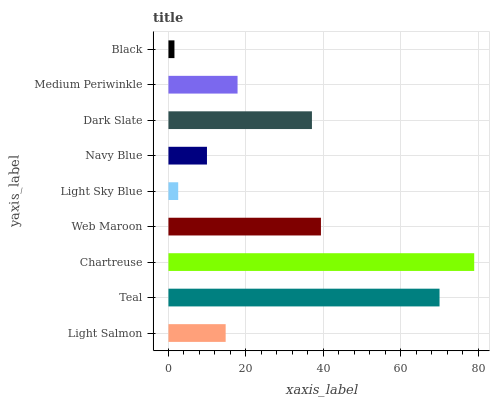Is Black the minimum?
Answer yes or no. Yes. Is Chartreuse the maximum?
Answer yes or no. Yes. Is Teal the minimum?
Answer yes or no. No. Is Teal the maximum?
Answer yes or no. No. Is Teal greater than Light Salmon?
Answer yes or no. Yes. Is Light Salmon less than Teal?
Answer yes or no. Yes. Is Light Salmon greater than Teal?
Answer yes or no. No. Is Teal less than Light Salmon?
Answer yes or no. No. Is Medium Periwinkle the high median?
Answer yes or no. Yes. Is Medium Periwinkle the low median?
Answer yes or no. Yes. Is Black the high median?
Answer yes or no. No. Is Dark Slate the low median?
Answer yes or no. No. 